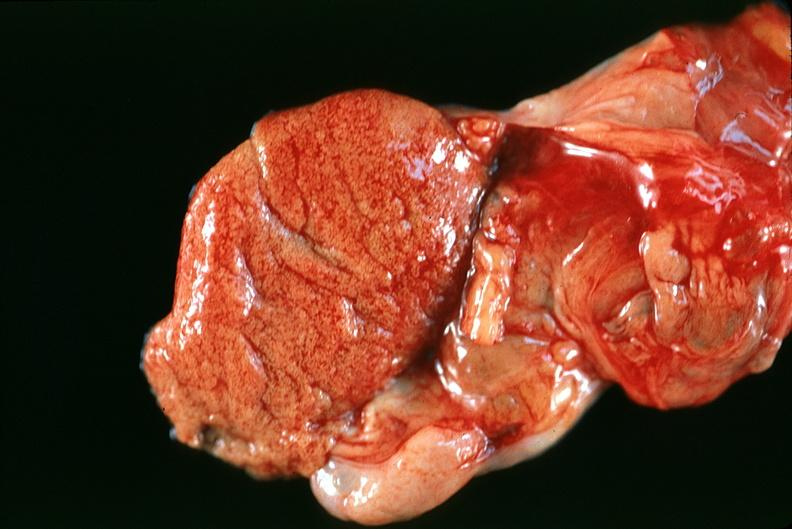what is present?
Answer the question using a single word or phrase. Male reproductive 